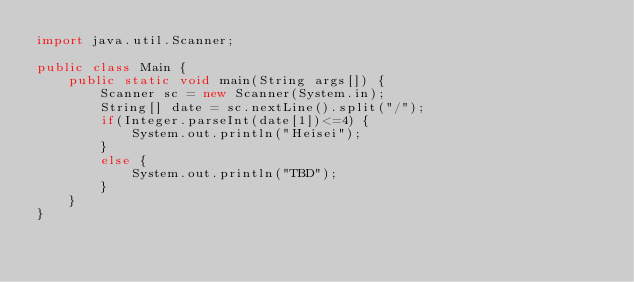<code> <loc_0><loc_0><loc_500><loc_500><_Java_>import java.util.Scanner;

public class Main {
	public static void main(String args[]) {
		Scanner sc = new Scanner(System.in);
		String[] date = sc.nextLine().split("/");
		if(Integer.parseInt(date[1])<=4) {
			System.out.println("Heisei");
		}
		else {
			System.out.println("TBD");
		}
	}
}</code> 